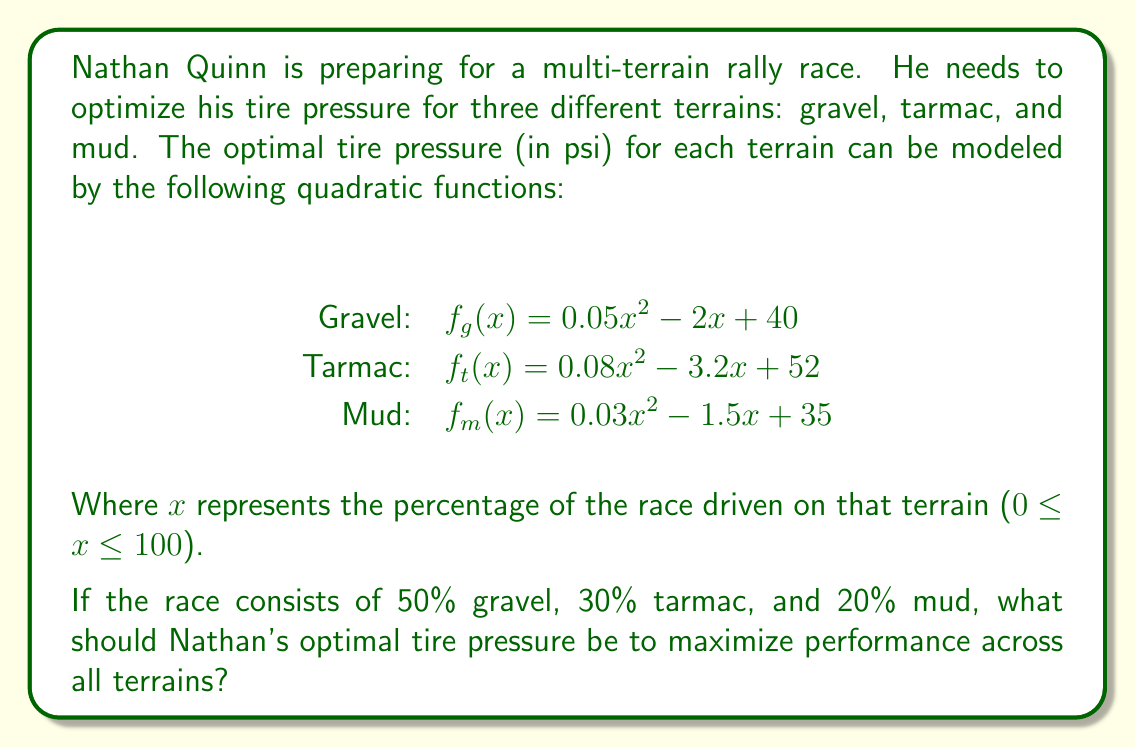Can you solve this math problem? To solve this problem, we need to follow these steps:

1. Find the optimal tire pressure for each terrain by calculating the minimum of each quadratic function.
2. Weight the optimal pressures by the percentage of each terrain in the race.
3. Sum the weighted pressures to get the overall optimal tire pressure.

Step 1: Finding the optimal pressure for each terrain

To find the minimum of a quadratic function $f(x) = ax^2 + bx + c$, we use the formula $x = -\frac{b}{2a}$.

For gravel: $f_g(x) = 0.05x^2 - 2x + 40$
$x_g = -\frac{-2}{2(0.05)} = 20$
Optimal pressure for gravel: $f_g(20) = 0.05(20)^2 - 2(20) + 40 = 20$ psi

For tarmac: $f_t(x) = 0.08x^2 - 3.2x + 52$
$x_t = -\frac{-3.2}{2(0.08)} = 20$
Optimal pressure for tarmac: $f_t(20) = 0.08(20)^2 - 3.2(20) + 52 = 20$ psi

For mud: $f_m(x) = 0.03x^2 - 1.5x + 35$
$x_m = -\frac{-1.5}{2(0.03)} = 25$
Optimal pressure for mud: $f_m(25) = 0.03(25)^2 - 1.5(25) + 35 = 16.25$ psi

Step 2: Weighting the optimal pressures

Gravel (50%): $0.50 \times 20 = 10$ psi
Tarmac (30%): $0.30 \times 20 = 6$ psi
Mud (20%): $0.20 \times 16.25 = 3.25$ psi

Step 3: Summing the weighted pressures

Total optimal pressure = $10 + 6 + 3.25 = 19.25$ psi
Answer: The optimal tire pressure for Nathan Quinn's rally race is 19.25 psi. 